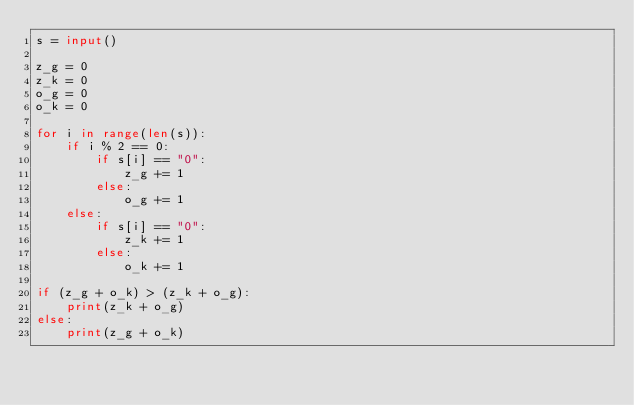<code> <loc_0><loc_0><loc_500><loc_500><_Python_>s = input()

z_g = 0
z_k = 0
o_g = 0
o_k = 0

for i in range(len(s)):
    if i % 2 == 0:
        if s[i] == "0":
            z_g += 1
        else:
            o_g += 1
    else:
        if s[i] == "0":
            z_k += 1
        else:
            o_k += 1

if (z_g + o_k) > (z_k + o_g):
    print(z_k + o_g)
else:
    print(z_g + o_k)</code> 